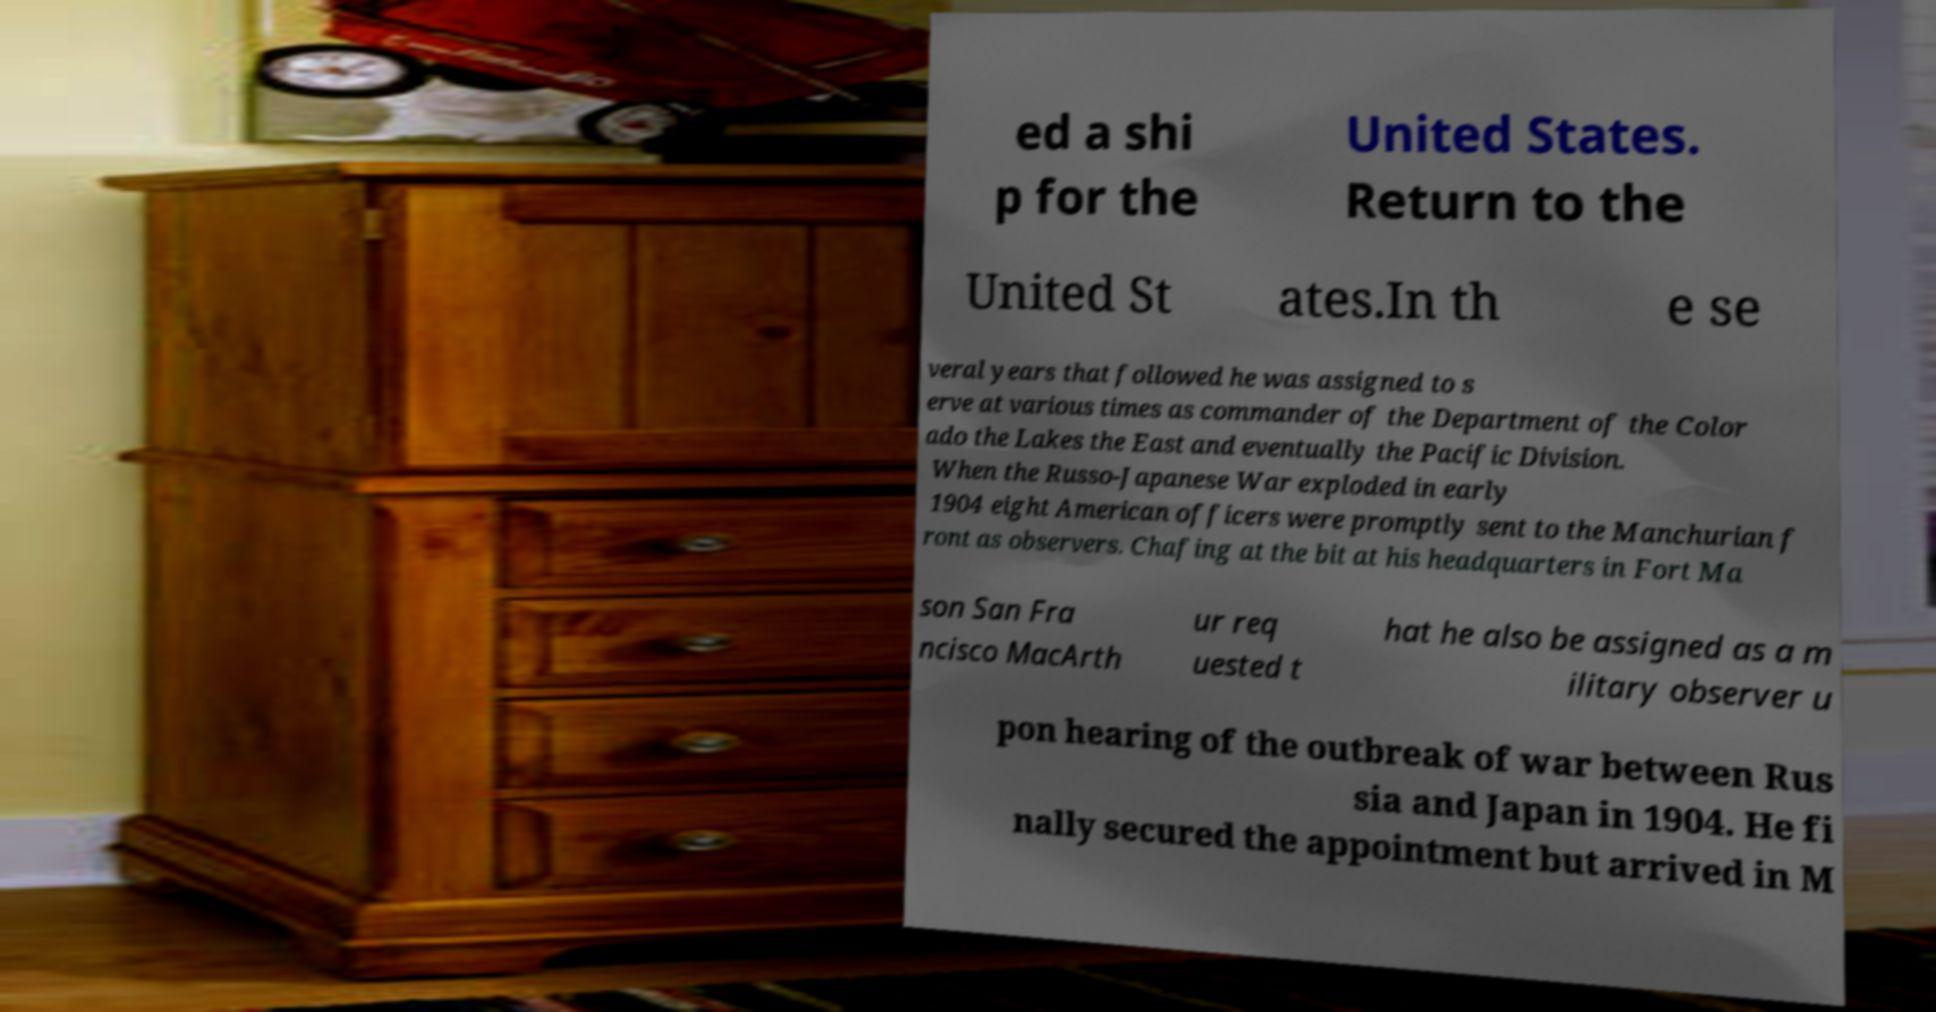Could you assist in decoding the text presented in this image and type it out clearly? ed a shi p for the United States. Return to the United St ates.In th e se veral years that followed he was assigned to s erve at various times as commander of the Department of the Color ado the Lakes the East and eventually the Pacific Division. When the Russo-Japanese War exploded in early 1904 eight American officers were promptly sent to the Manchurian f ront as observers. Chafing at the bit at his headquarters in Fort Ma son San Fra ncisco MacArth ur req uested t hat he also be assigned as a m ilitary observer u pon hearing of the outbreak of war between Rus sia and Japan in 1904. He fi nally secured the appointment but arrived in M 